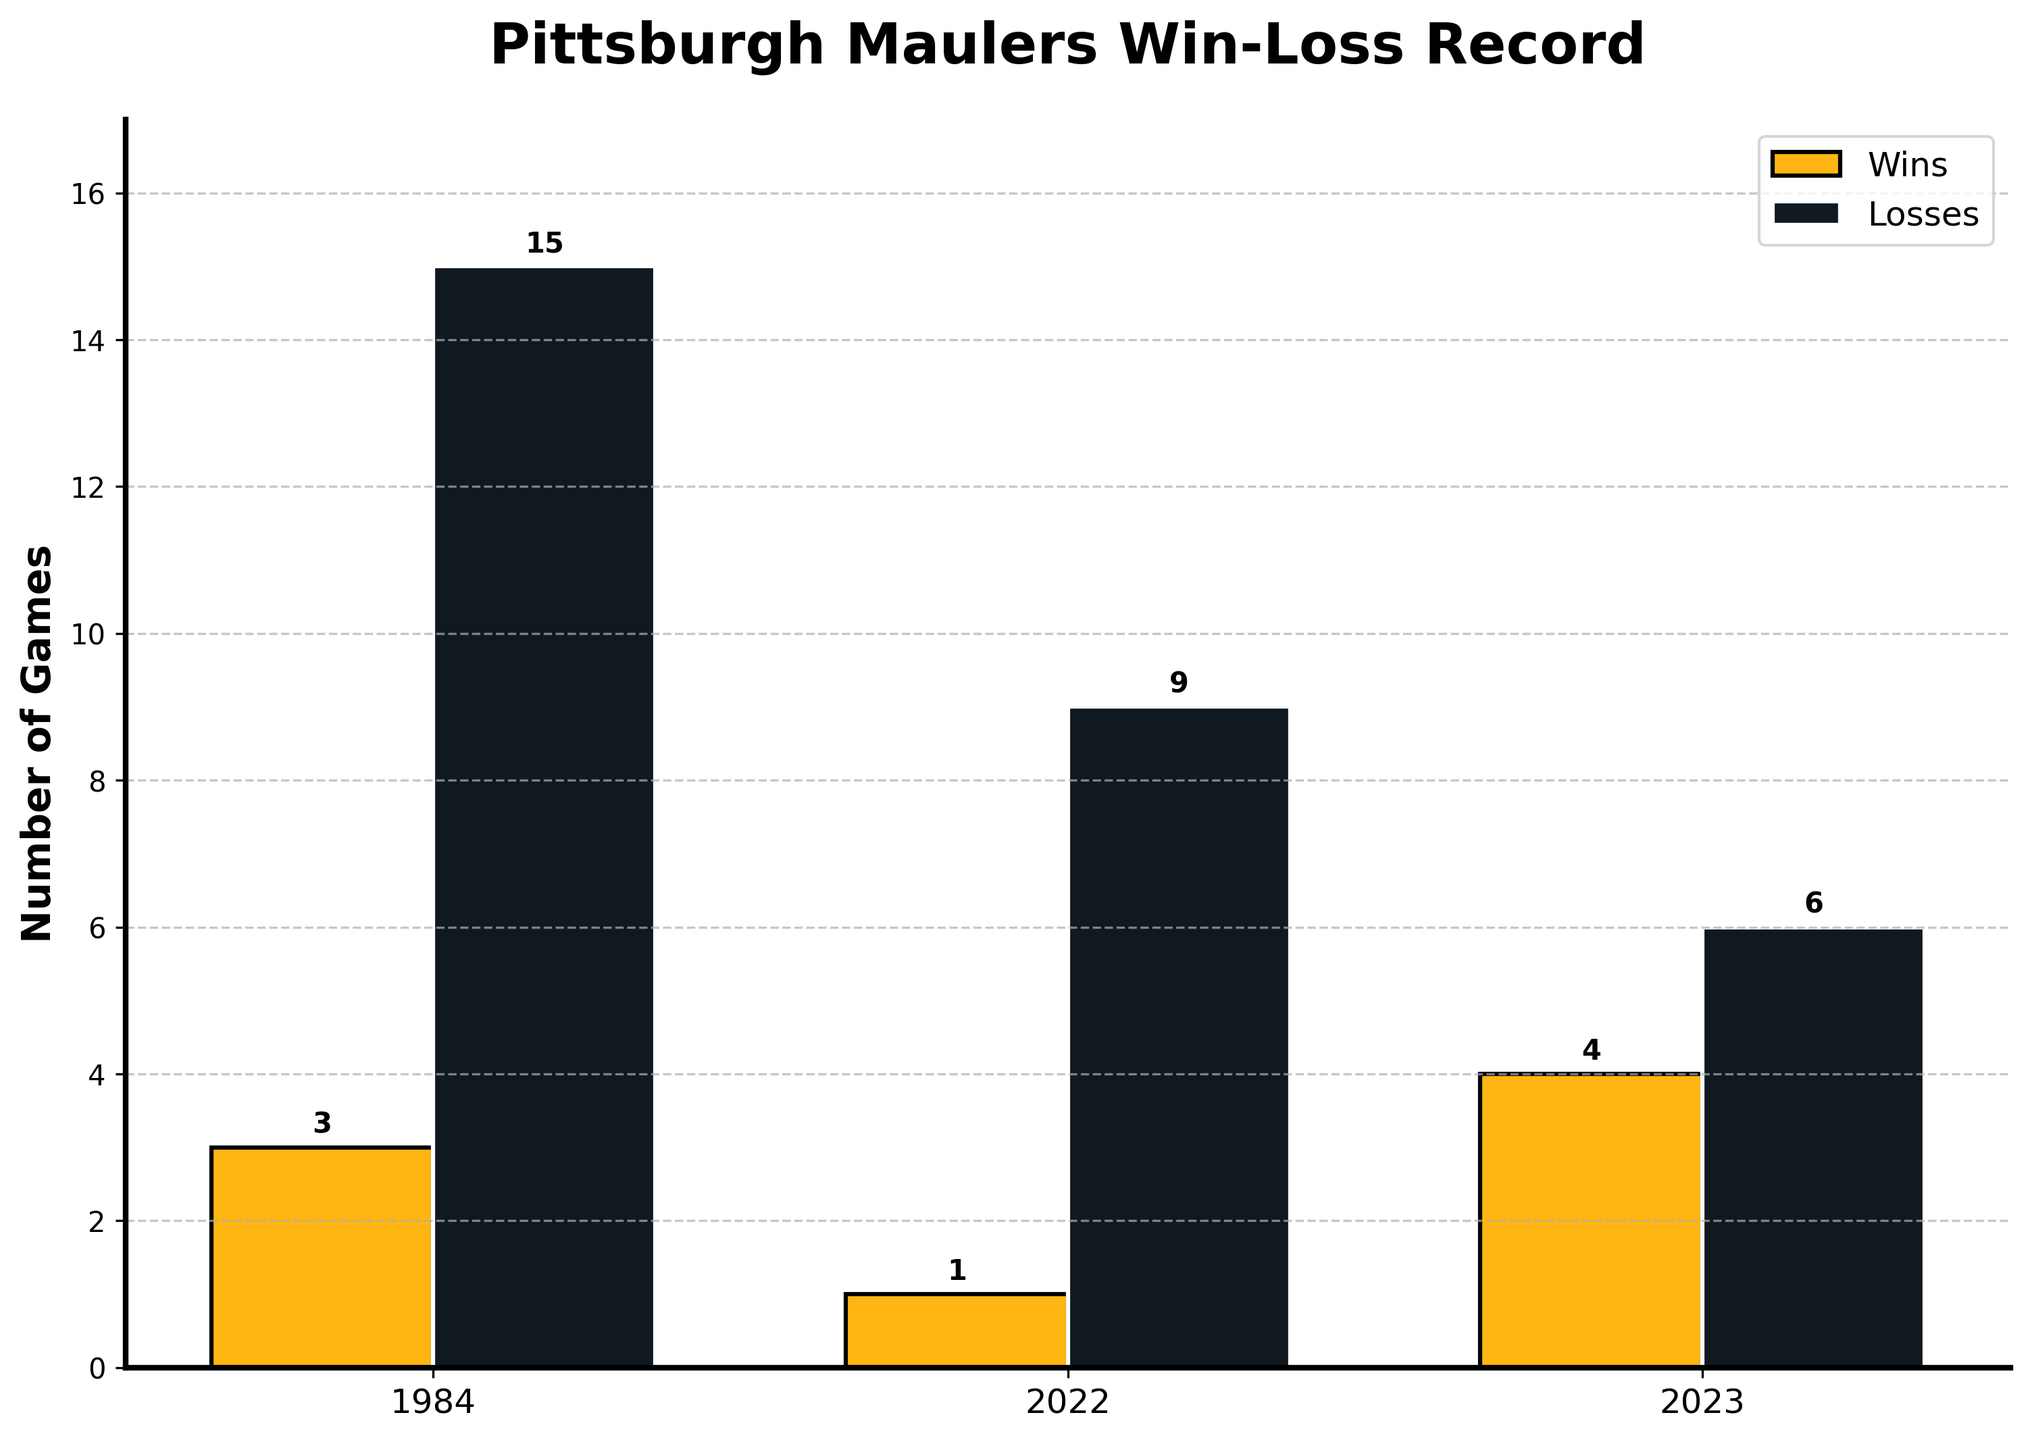How many losses did the Pittsburgh Maulers have in 1984? Looking at the bar representing the year 1984, the height of the "Losses" bar indicates the number 15.
Answer: 15 In which season did the Pittsburgh Maulers have the highest number of wins? By comparing the heights of the "Wins" bars across all the seasons, the highest bar appears in the year 2023 with a count of 4 wins.
Answer: 2023 What is the total number of wins and losses for the Pittsburgh Maulers from all the seasons? Summing up the "Wins" for all seasons (3 + 1 + 4 = 8) and "Losses" (15 + 9 + 6 = 30) gives us the totals.
Answer: Wins: 8, Losses: 30 How many more losses did the Pittsburgh Maulers have in 2022 compared to 1984? Subtract the number of losses in 1984 (15) from the number of losses in 2022 (9). The calculation is 9 - 15 = -6. Since the result is negative, the Maulers actually had 6 more losses in 1984.
Answer: 6 more in 1984 What is the difference between the number of wins in 1984 and 2022? Subtract the number of wins in 2022 (1) from the number of wins in 1984 (3). The calculation is 3 - 1 = 2.
Answer: 2 Which season had the fewest wins, and how many wins were there? Comparing the "Wins" bars, the shortest bar appears in 2022 with a count of 1 win.
Answer: 2022, 1 win How many total games did the Pittsburgh Maulers play in 2023? Sum the number of wins and losses in 2023 (4 wins + 6 losses). The calculation is 4 + 6 = 10.
Answer: 10 Did the Pittsburgh Maulers win more games in 1984 or 2023? Comparing the "Wins" bars for 1984 and 2023, 2023 shows a higher count with 4 wins, while 1984 has 3 wins.
Answer: 2023 